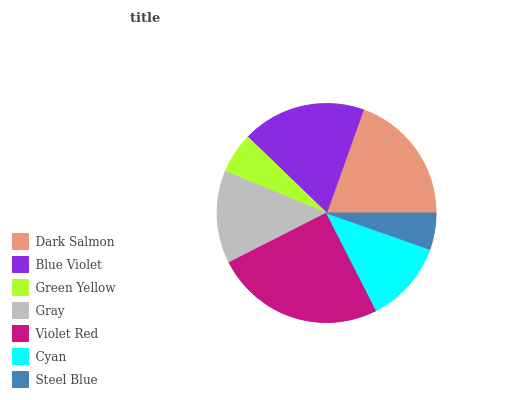Is Steel Blue the minimum?
Answer yes or no. Yes. Is Violet Red the maximum?
Answer yes or no. Yes. Is Blue Violet the minimum?
Answer yes or no. No. Is Blue Violet the maximum?
Answer yes or no. No. Is Dark Salmon greater than Blue Violet?
Answer yes or no. Yes. Is Blue Violet less than Dark Salmon?
Answer yes or no. Yes. Is Blue Violet greater than Dark Salmon?
Answer yes or no. No. Is Dark Salmon less than Blue Violet?
Answer yes or no. No. Is Gray the high median?
Answer yes or no. Yes. Is Gray the low median?
Answer yes or no. Yes. Is Blue Violet the high median?
Answer yes or no. No. Is Steel Blue the low median?
Answer yes or no. No. 